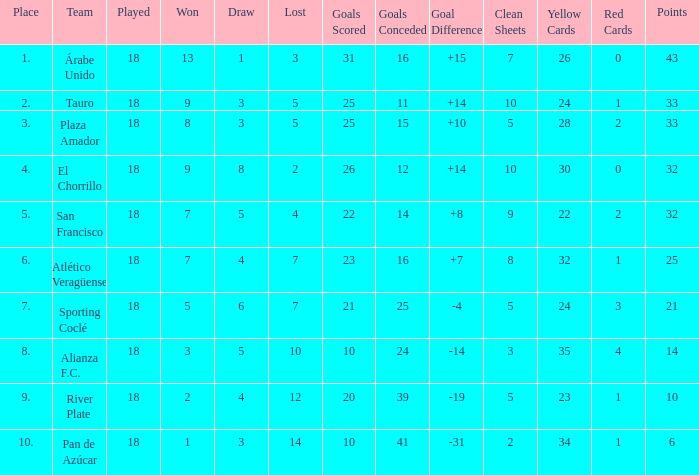How many goals were conceded by the team with more than 21 points more than 5 draws and less than 18 games played? None. 